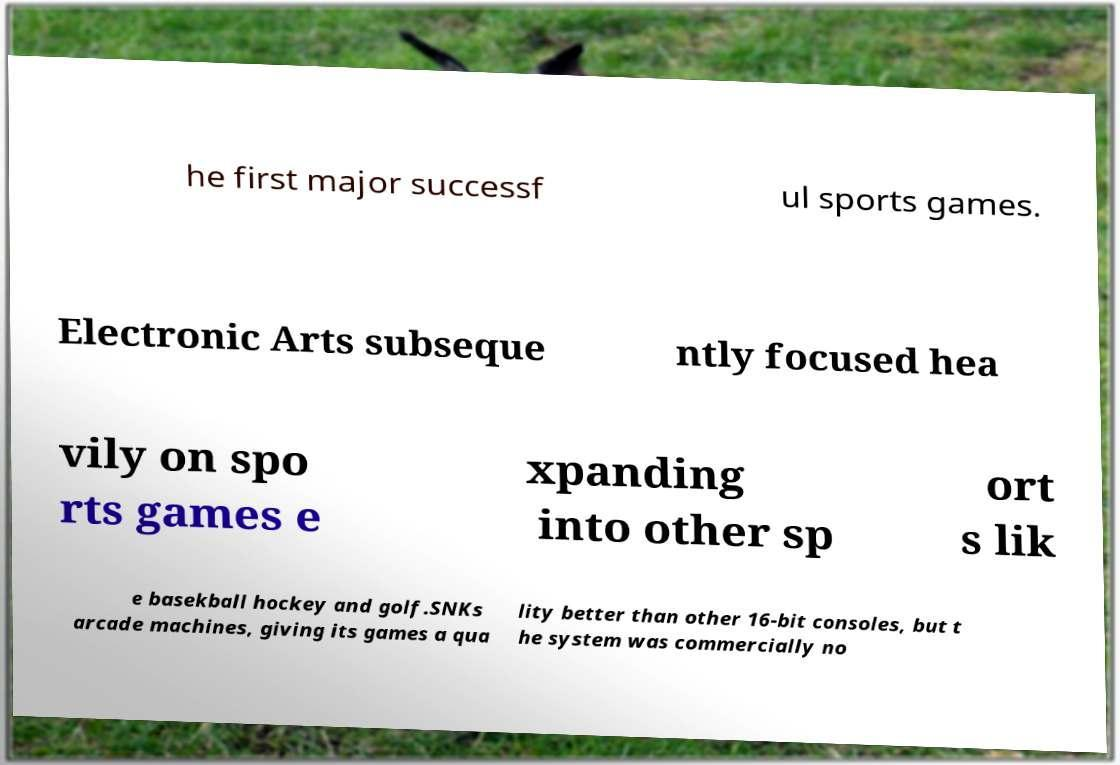Could you extract and type out the text from this image? he first major successf ul sports games. Electronic Arts subseque ntly focused hea vily on spo rts games e xpanding into other sp ort s lik e basekball hockey and golf.SNKs arcade machines, giving its games a qua lity better than other 16-bit consoles, but t he system was commercially no 